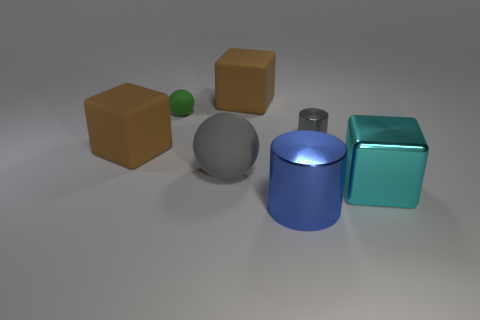What number of rubber spheres have the same color as the tiny cylinder?
Keep it short and to the point. 1. What number of gray balls have the same material as the gray cylinder?
Offer a terse response. 0. How many objects are either big matte spheres or big objects left of the cyan object?
Offer a very short reply. 4. There is a block that is in front of the large brown block that is to the left of the brown matte thing that is behind the small green sphere; what is its color?
Your answer should be very brief. Cyan. There is a gray cylinder left of the large metal cube; what size is it?
Keep it short and to the point. Small. What number of small things are either gray matte balls or blue cylinders?
Give a very brief answer. 0. There is a object that is both right of the blue metallic cylinder and behind the cyan shiny object; what is its color?
Provide a succinct answer. Gray. Are there any gray matte things of the same shape as the tiny green matte object?
Make the answer very short. Yes. What is the material of the big blue cylinder?
Keep it short and to the point. Metal. Are there any big brown things right of the large matte sphere?
Provide a short and direct response. Yes. 